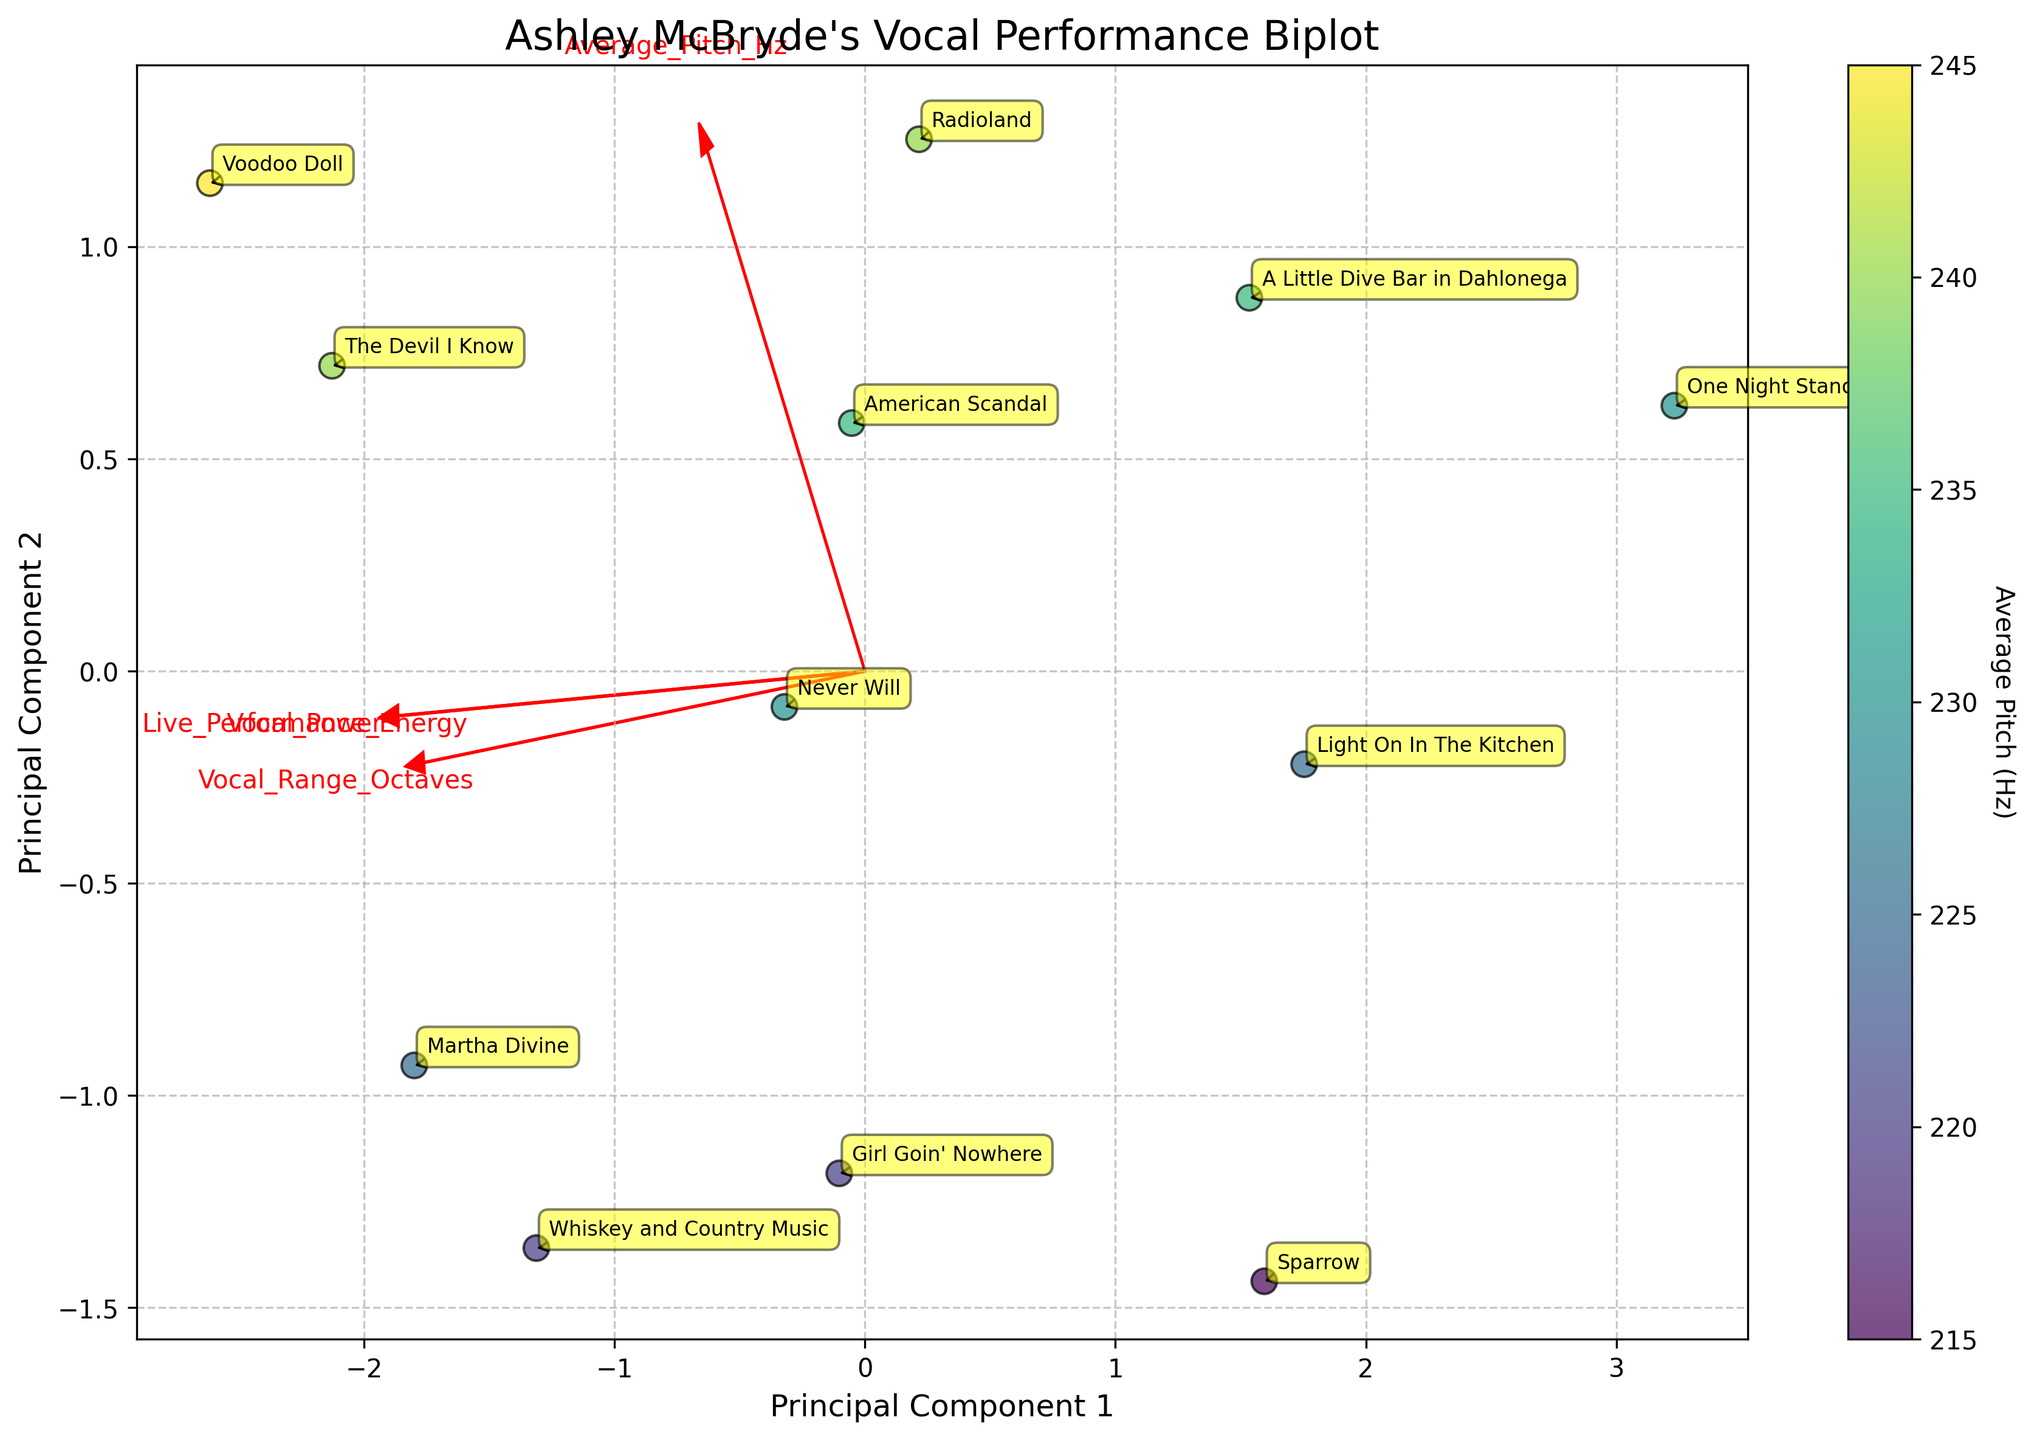What is the title of the plot? The title of the plot is located at the top and should provide an overview of what the plot represents. Here, it is specifically about Ashley McBryde's vocal performance.
Answer: Ashley McBryde's Vocal Performance Biplot How many songs are plotted in the Biplot? You can count the number of distinct data points in the Biplot to determine the number of songs. Each point represents one song. There are 12 points, each labeled with a song title.
Answer: 12 What does the color of the data points indicate? The color of the data points is determined by a color map shown in the color bar on the right side of the plot. The label on the color bar indicates that the color represents the "Average Pitch (Hz)" of each song.
Answer: Average Pitch (Hz) Which song has the highest Average Pitch? By referring to the color intensity and the annotations on the Biplot, we look for the darkest (representing highest pitch) annotated point. "Voodoo Doll" appears to have the darkest color, indicating the highest average pitch.
Answer: Voodoo Doll Which songs have the highest Live Performance Energy? The features Live Performance Energy and Vocal Power are plotted as vectors in the Biplot. The longest vectors in the directions labeled "Live Performance Energy" should point to the relevant data points. Songs like "Martha Divine," "Whiskey and Country Music," "The Devil I Know," and "Voodoo Doll" are close to the end of this vector, indicating high performance energy.
Answer: Martha Divine, Whiskey and Country Music, The Devil I Know, Voodoo Doll What do the arrows (feature vectors) represent in the Biplot? The arrows represent the direction and magnitude of each feature such as Vocal_Range_Octaves, Average_Pitch_Hz, Live_Performance_Energy, and Vocal_Power. The direction indicates how much the feature contributes to each principal component, and the length indicates the strength of that contribution.
Answer: Feature contributions to Principal Components Which song has the lowest Vocal Power based on the Biplot? Looking at the direction of the "Vocal Power" vector, the data point furthest from the tip of this vector represents the lowest Vocal Power. "One Night Standards" is far from this vector’s direction.
Answer: One Night Standards What combination of Principal Components describes the song "Radioland"? Each song is represented as a point based on principal component (PC1) and principal component (PC2) values. By locating "Radioland" on the plot, we can see its position relative to the origin and other points. It is moderately positive on both PC1 and PC2.
Answer: Moderately positive on PC1 and PC2 Does "American Scandal" have a higher or lower Average Pitch than "Whiskey and Country Music"? To compare averages of pitch, refer to the color intensity where lighter represents a higher pitch. "American Scandal" and "Whiskey and Country Music" have similar hues, but "Whiskey and Country Music" appears slightly darker.
Answer: Lower Which principal component axis (PC1 or PC2) appears to capture more variance in the features? The longer axis usually captures more variance. Given no explicit eigenvalues plotted but considering typical PCA convention, the plot placement of vectors closer to the PC1 arrow suggests PC1 is capturing more feature variance.
Answer: PC1 